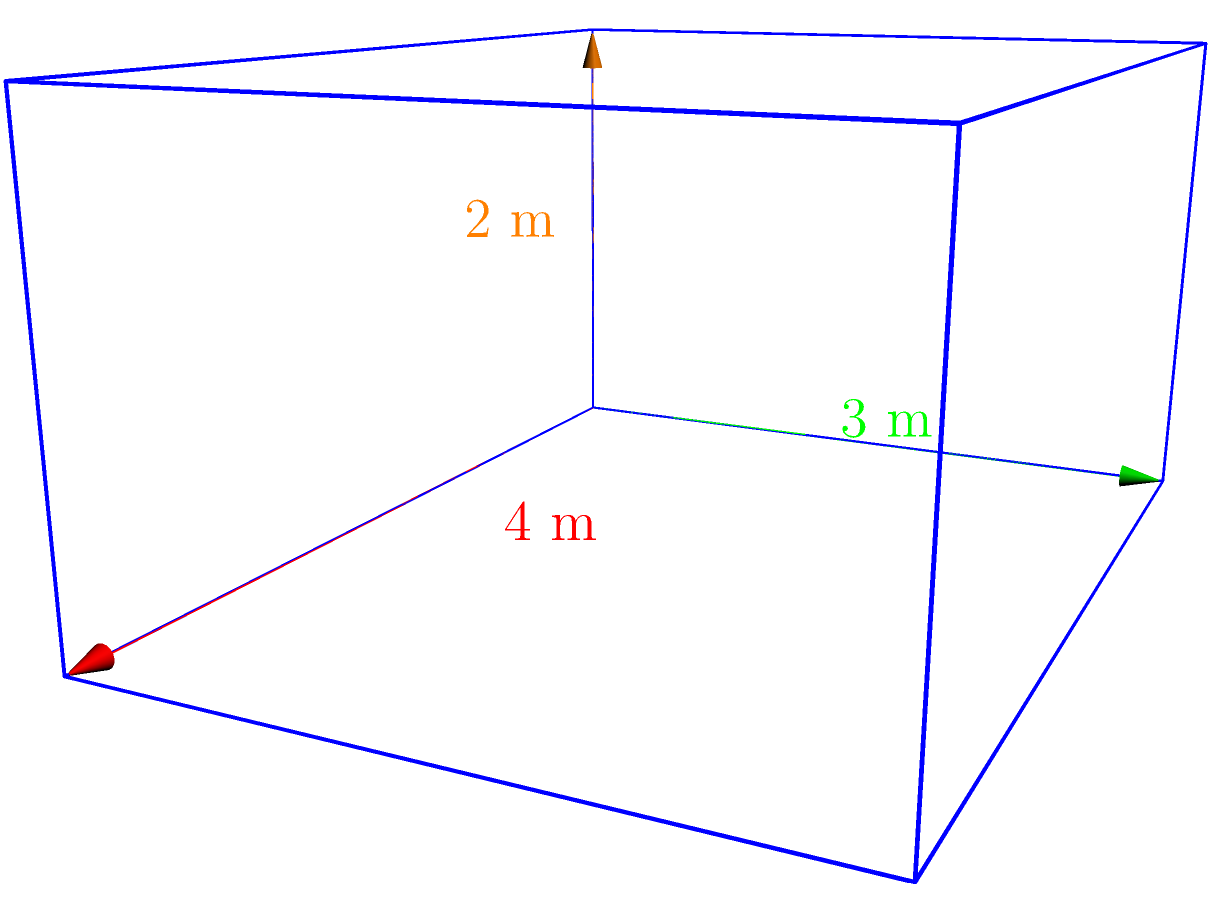As a marketing coordinator overseeing web development projects, you're tasked with creating a 3D model of a product display case for an e-commerce website. The display case is a rectangular prism with dimensions 4 meters long, 3 meters wide, and 2 meters high. Calculate the volume of this display case in cubic meters. To calculate the volume of a rectangular prism, we use the formula:

$$ V = l \times w \times h $$

Where:
$V$ = volume
$l$ = length
$w$ = width
$h$ = height

Given dimensions:
- Length ($l$) = 4 meters
- Width ($w$) = 3 meters
- Height ($h$) = 2 meters

Let's substitute these values into the formula:

$$ V = 4 \text{ m} \times 3 \text{ m} \times 2 \text{ m} $$

$$ V = 24 \text{ m}^3 $$

Therefore, the volume of the rectangular prism (display case) is 24 cubic meters.
Answer: $24 \text{ m}^3$ 